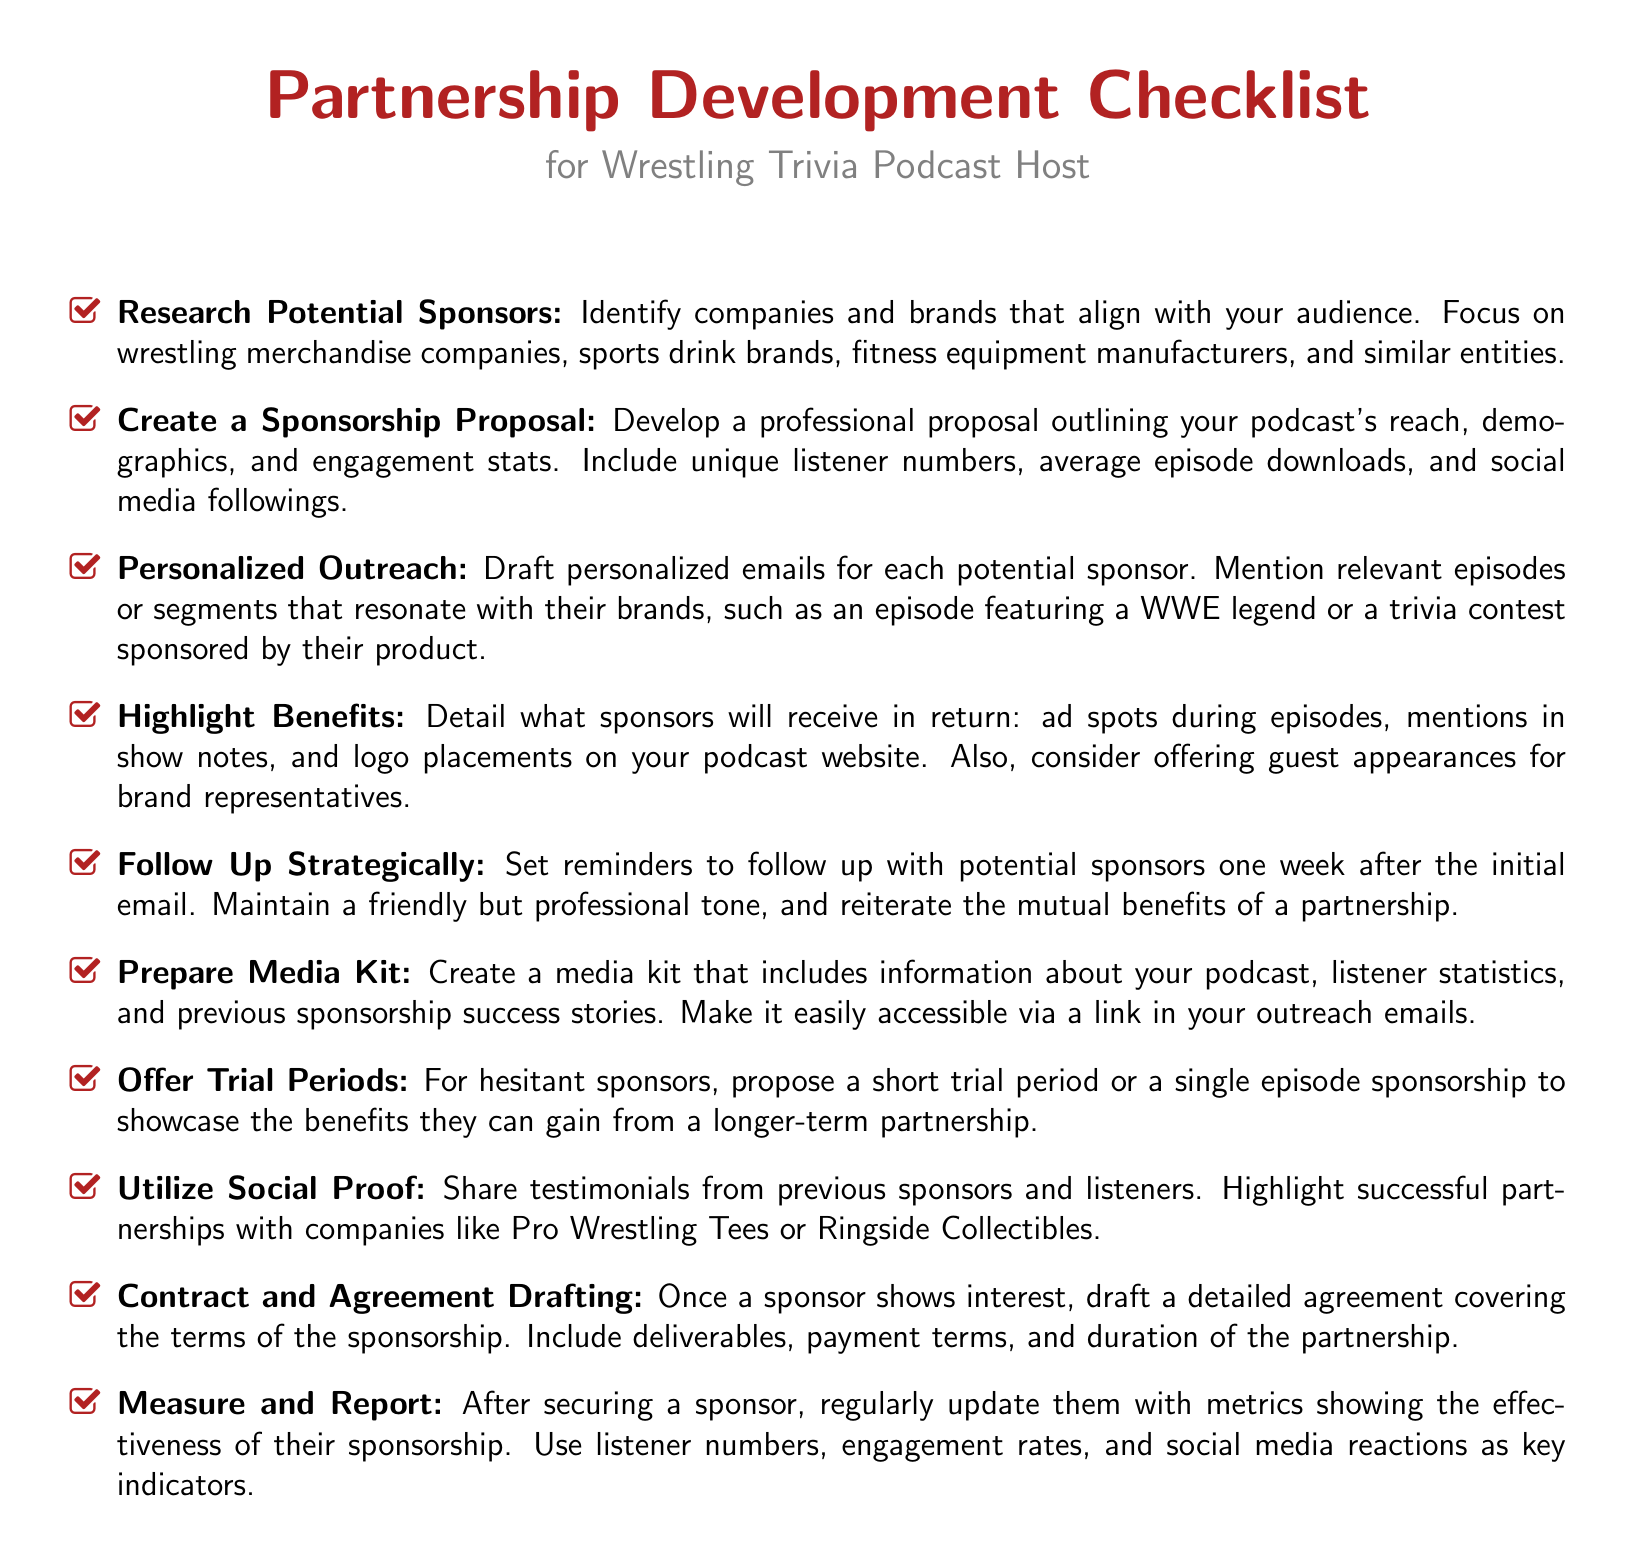What is the target audience for potential sponsors? The target audience includes companies and brands that align with wrestling culture, specifically wrestling merchandise companies and sports drink brands.
Answer: wrestling merchandise companies, sports drink brands How many items are in the checklist? The checklist contains 10 specific tasks related to partnership development for a podcast host.
Answer: 10 What should you include in a sponsorship proposal? A sponsorship proposal should include details about the podcast's reach and engagement stats, such as unique listener numbers and average episode downloads.
Answer: unique listener numbers, average episode downloads When should you follow up with potential sponsors? The checklist specifies to follow up with potential sponsors one week after sending the initial email.
Answer: one week What can sponsors receive in return? Sponsors can receive ad spots during episodes, mentions in show notes, and logo placements on the podcast website as part of their sponsorship benefits.
Answer: ad spots, mentions in show notes, logo placements What should you create to showcase previous success stories? You should create a media kit that highlights previous sponsorship success stories along with listener statistics.
Answer: media kit What strategy is suggested for hesitant sponsors? The checklist suggests offering a short trial period or a single episode sponsorship to build confidence in the partnership.
Answer: short trial period What is emphasized to add credibility to outreach? Utilizing social proof, such as testimonials from previous sponsors and successful partnerships, is emphasized to add credibility.
Answer: testimonials 